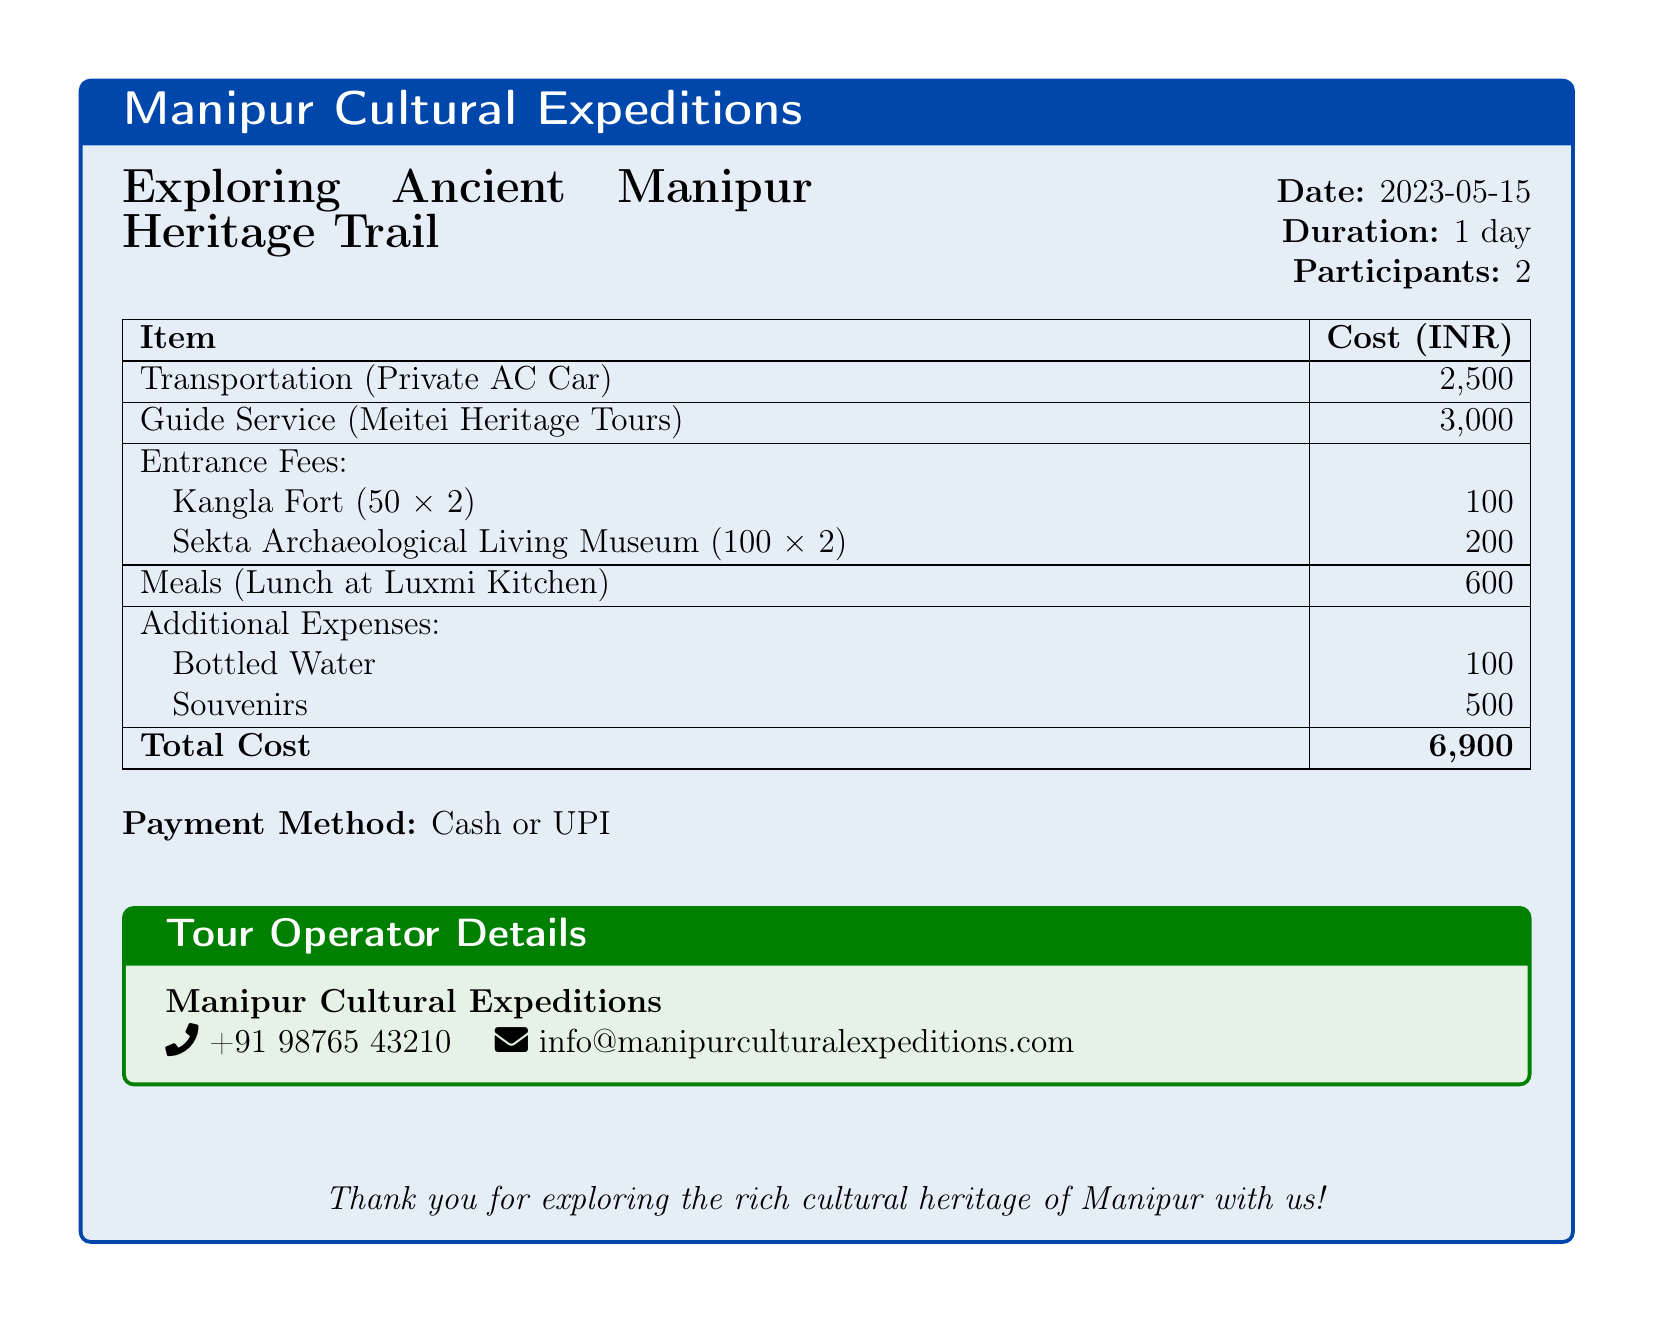what is the date of the tour? The date of the tour is stated in the document as '2023-05-15'.
Answer: 2023-05-15 how many participants were there? The document specifies that there were '2' participants on the tour.
Answer: 2 what is the total cost of the tour? The total cost of the tour is provided at the end of the cost breakdown as '6,900 INR'.
Answer: 6,900 what is the name of the tour operator? The document lists the tour operator's name as 'Manipur Cultural Expeditions'.
Answer: Manipur Cultural Expeditions how much was spent on transportation? The document states that the cost for transportation is '2,500 INR'.
Answer: 2,500 what is the cost of the guide service? The document mentions that the guide service cost is '3,000 INR'.
Answer: 3,000 how much did the entrance fees total? The entrance fees for both locations are detailed, totaling '300 INR'.
Answer: 300 what was the cost of lunch? The cost for lunch is mentioned as '600 INR' in the expenses.
Answer: 600 what payment methods are accepted? The document indicates that payment can be made by 'Cash or UPI'.
Answer: Cash or UPI 